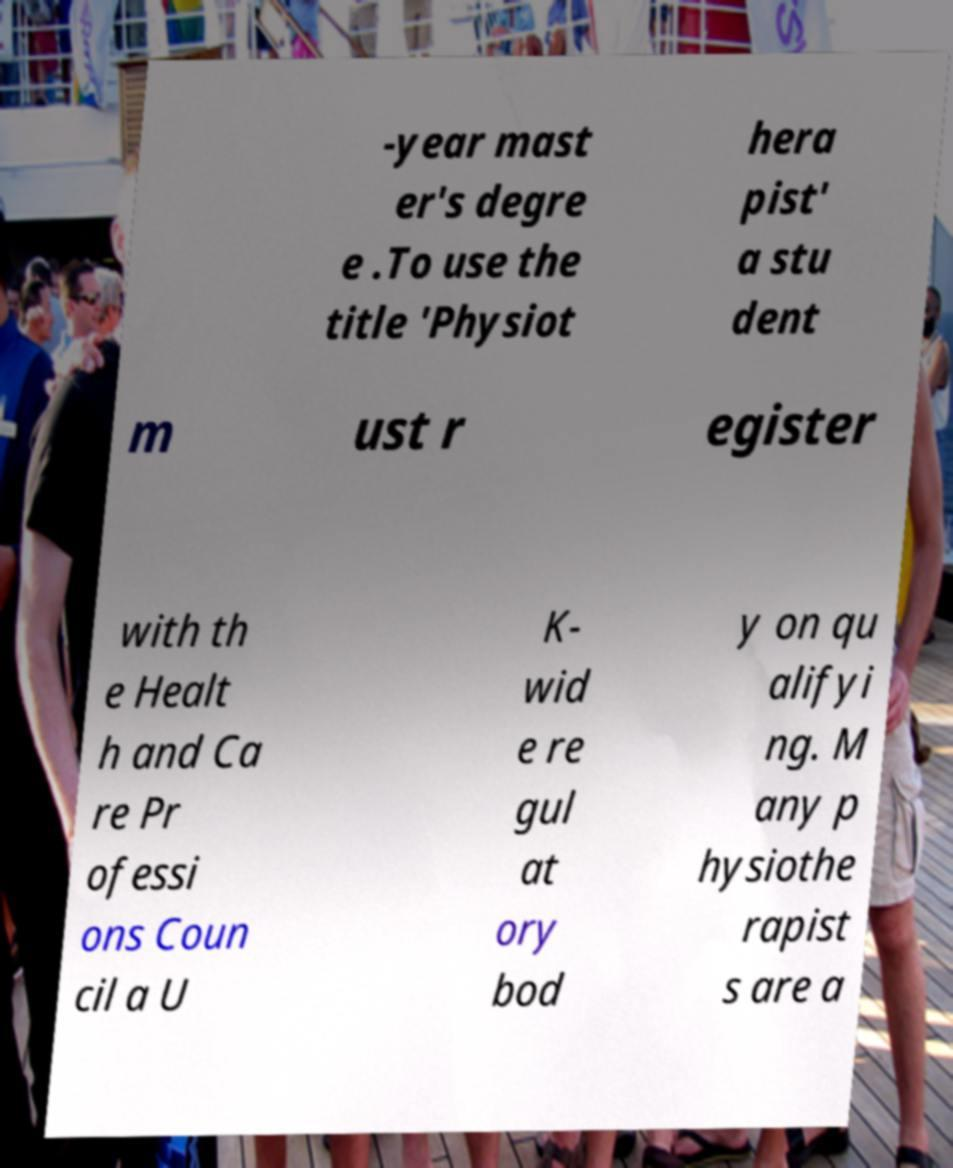Please read and relay the text visible in this image. What does it say? -year mast er's degre e .To use the title 'Physiot hera pist' a stu dent m ust r egister with th e Healt h and Ca re Pr ofessi ons Coun cil a U K- wid e re gul at ory bod y on qu alifyi ng. M any p hysiothe rapist s are a 